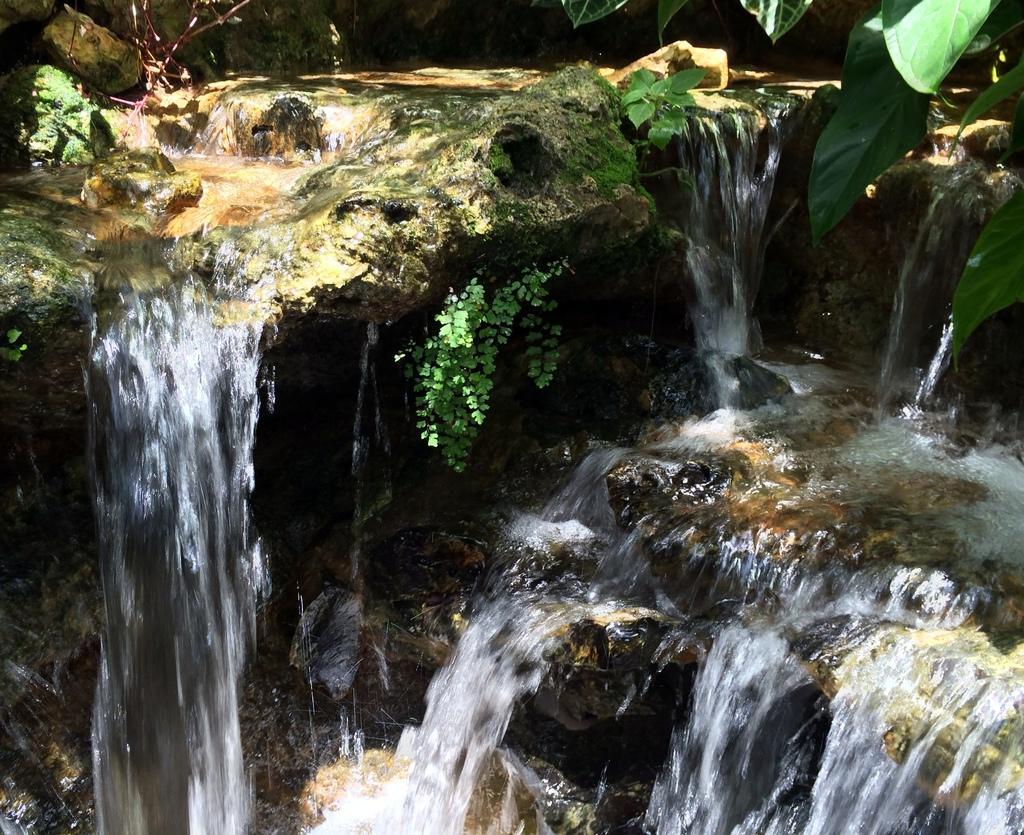How would you summarize this image in a sentence or two? In this image I can see in the middle water is flowing, there are plants. In the right hand side top there are green leaves. 